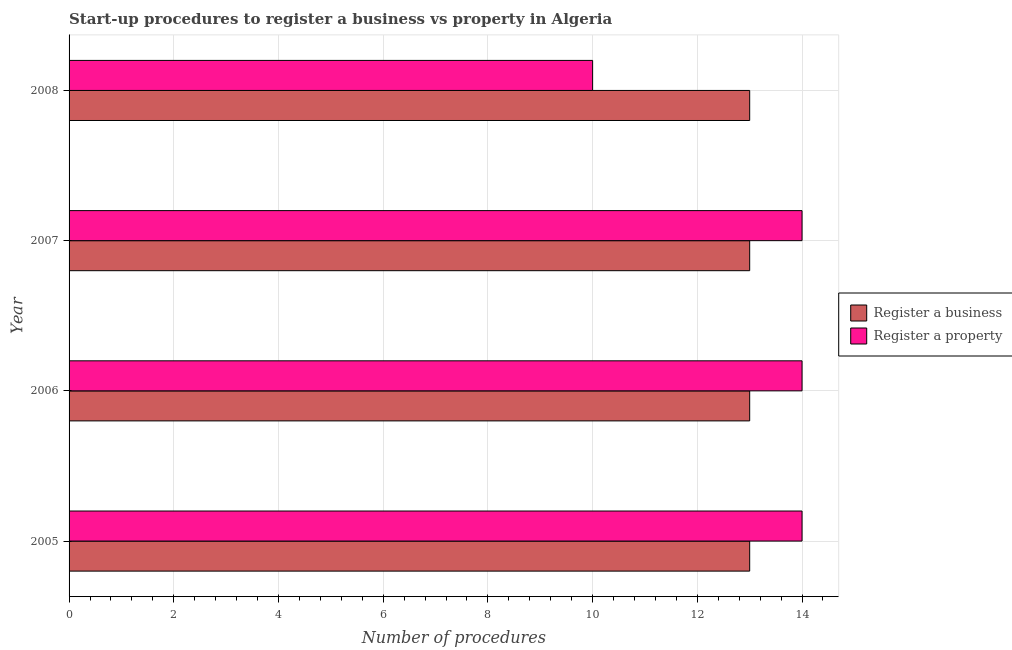Are the number of bars per tick equal to the number of legend labels?
Offer a terse response. Yes. How many bars are there on the 3rd tick from the bottom?
Provide a succinct answer. 2. What is the label of the 1st group of bars from the top?
Your response must be concise. 2008. What is the number of procedures to register a property in 2006?
Provide a short and direct response. 14. Across all years, what is the maximum number of procedures to register a property?
Your answer should be very brief. 14. Across all years, what is the minimum number of procedures to register a property?
Give a very brief answer. 10. In which year was the number of procedures to register a property maximum?
Provide a succinct answer. 2005. What is the total number of procedures to register a business in the graph?
Offer a terse response. 52. What is the difference between the number of procedures to register a property in 2005 and that in 2008?
Keep it short and to the point. 4. What is the difference between the number of procedures to register a property in 2008 and the number of procedures to register a business in 2005?
Provide a succinct answer. -3. In the year 2008, what is the difference between the number of procedures to register a business and number of procedures to register a property?
Offer a terse response. 3. What is the ratio of the number of procedures to register a business in 2005 to that in 2007?
Your answer should be very brief. 1. Is the number of procedures to register a property in 2005 less than that in 2007?
Offer a terse response. No. What is the difference between the highest and the lowest number of procedures to register a property?
Provide a succinct answer. 4. In how many years, is the number of procedures to register a business greater than the average number of procedures to register a business taken over all years?
Your answer should be compact. 0. What does the 1st bar from the top in 2006 represents?
Give a very brief answer. Register a property. What does the 2nd bar from the bottom in 2006 represents?
Make the answer very short. Register a property. Where does the legend appear in the graph?
Your answer should be very brief. Center right. How many legend labels are there?
Provide a short and direct response. 2. How are the legend labels stacked?
Your answer should be very brief. Vertical. What is the title of the graph?
Make the answer very short. Start-up procedures to register a business vs property in Algeria. Does "Adolescent fertility rate" appear as one of the legend labels in the graph?
Give a very brief answer. No. What is the label or title of the X-axis?
Make the answer very short. Number of procedures. What is the Number of procedures in Register a property in 2005?
Your response must be concise. 14. What is the Number of procedures in Register a property in 2007?
Give a very brief answer. 14. What is the Number of procedures of Register a business in 2008?
Make the answer very short. 13. What is the Number of procedures of Register a property in 2008?
Offer a terse response. 10. Across all years, what is the minimum Number of procedures of Register a business?
Make the answer very short. 13. What is the total Number of procedures of Register a business in the graph?
Offer a very short reply. 52. What is the total Number of procedures in Register a property in the graph?
Give a very brief answer. 52. What is the difference between the Number of procedures in Register a business in 2005 and that in 2006?
Make the answer very short. 0. What is the difference between the Number of procedures in Register a property in 2005 and that in 2006?
Keep it short and to the point. 0. What is the difference between the Number of procedures of Register a business in 2005 and that in 2008?
Provide a succinct answer. 0. What is the difference between the Number of procedures of Register a property in 2005 and that in 2008?
Provide a succinct answer. 4. What is the difference between the Number of procedures in Register a business in 2006 and that in 2007?
Make the answer very short. 0. What is the difference between the Number of procedures of Register a property in 2006 and that in 2007?
Your answer should be very brief. 0. What is the difference between the Number of procedures of Register a business in 2006 and that in 2008?
Make the answer very short. 0. What is the difference between the Number of procedures of Register a property in 2006 and that in 2008?
Offer a very short reply. 4. What is the difference between the Number of procedures in Register a property in 2007 and that in 2008?
Your answer should be compact. 4. What is the difference between the Number of procedures in Register a business in 2005 and the Number of procedures in Register a property in 2008?
Keep it short and to the point. 3. What is the difference between the Number of procedures of Register a business in 2006 and the Number of procedures of Register a property in 2008?
Your response must be concise. 3. What is the difference between the Number of procedures of Register a business in 2007 and the Number of procedures of Register a property in 2008?
Provide a short and direct response. 3. What is the average Number of procedures in Register a business per year?
Offer a very short reply. 13. What is the average Number of procedures in Register a property per year?
Offer a very short reply. 13. In the year 2006, what is the difference between the Number of procedures of Register a business and Number of procedures of Register a property?
Give a very brief answer. -1. In the year 2008, what is the difference between the Number of procedures in Register a business and Number of procedures in Register a property?
Offer a very short reply. 3. What is the ratio of the Number of procedures in Register a property in 2005 to that in 2007?
Make the answer very short. 1. What is the ratio of the Number of procedures in Register a business in 2005 to that in 2008?
Offer a very short reply. 1. What is the ratio of the Number of procedures of Register a property in 2006 to that in 2007?
Provide a short and direct response. 1. What is the ratio of the Number of procedures of Register a business in 2006 to that in 2008?
Your answer should be very brief. 1. What is the difference between the highest and the lowest Number of procedures in Register a property?
Your answer should be very brief. 4. 